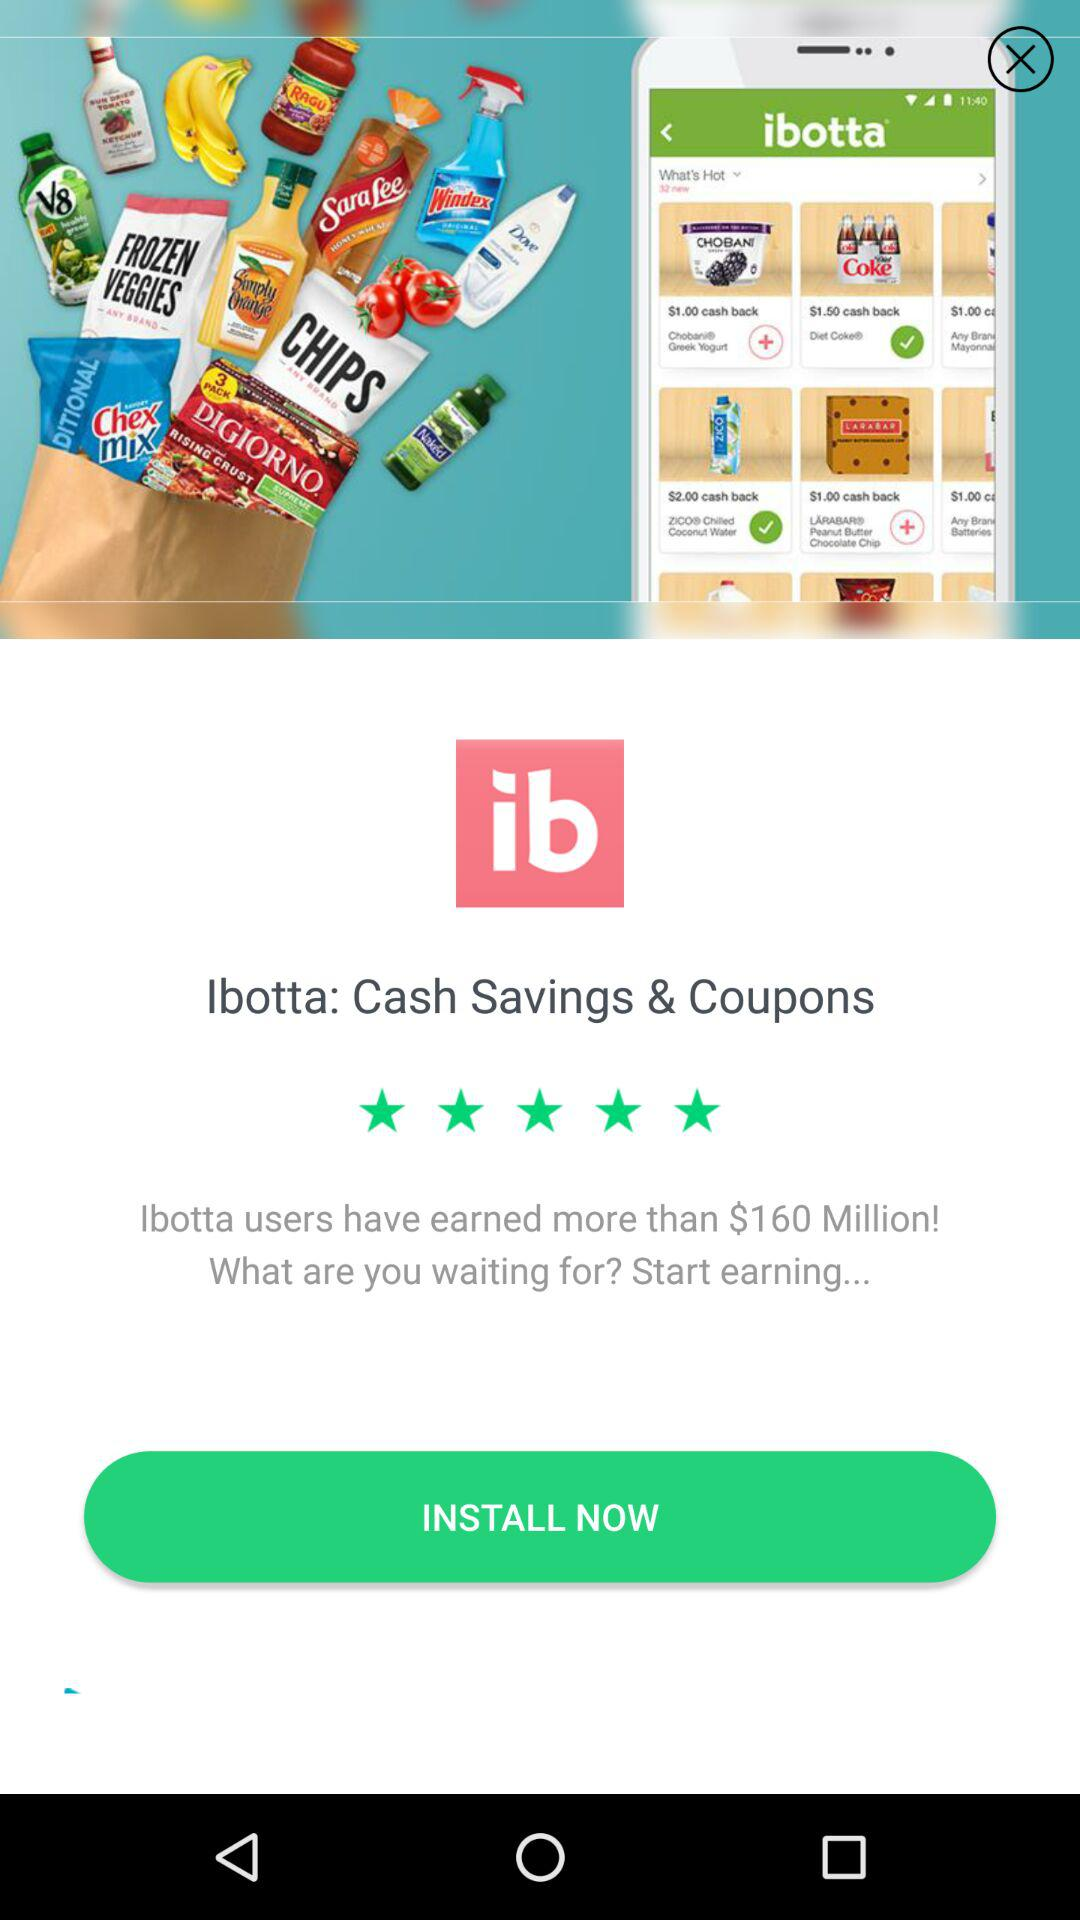Will the user install the application?
When the provided information is insufficient, respond with <no answer>. <no answer> 